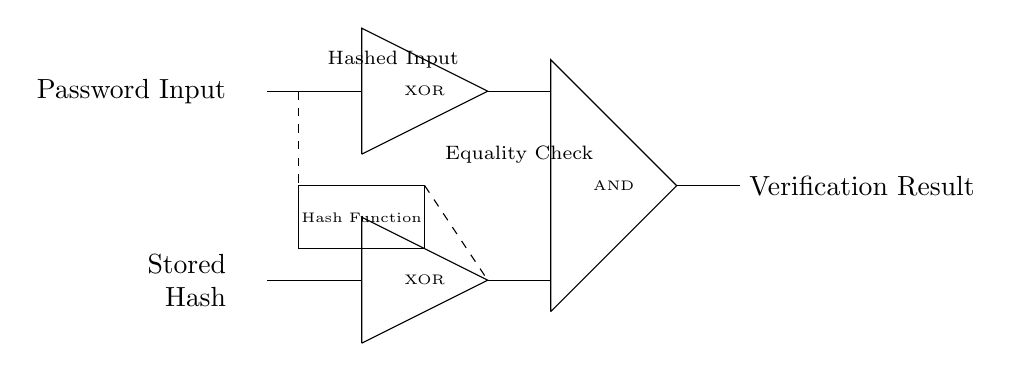What are the main components of this circuit? The circuit consists of two XOR gates, one AND gate, a hash function, a password input, and a stored hash. Each component has a specific role in the password verification process, with XOR gates comparing the input with the stored hash, and the AND gate producing the final verification result.
Answer: XOR gates, AND gate, hash function, password input, stored hash What does the output of the AND gate signify? The output of the AND gate signifies the overall verification result of the input password against the stored hash. If both inputs to the AND gate (from the XOR gates) are true (or high), then the AND gate will output true, indicating that the password is verified correctly.
Answer: Verification result How many XOR gates are present in this circuit? There are two XOR gates in the circuit, each responsible for comparing part of the input password against the stored hash.
Answer: Two What is the purpose of the hash function in this circuit? The hash function processes the password input to produce a hashed version, which is then compared with the stored hash to ensure security. This step is crucial as it transforms the password into a fixed-size string, protecting it from direct exposure and enhancing security.
Answer: To produce a hashed version of the password What happens if the inputs to the XOR gates are not equal? If the inputs to the XOR gates are not equal, the output of the XOR gate will be true, indicating a mismatch with the stored hash. This mismatch will eventually lead to the overall output of the AND gate being false, thereby failing the password verification process.
Answer: The XOR outputs true What components directly connect to the inputs of the AND gate? The inputs of the AND gate are connected to the outputs of the two XOR gates. This implies that the AND gate will receive signals based on the evaluations of those XOR gates, determining if both comparisons are valid for verification.
Answer: The outputs of the XOR gates 